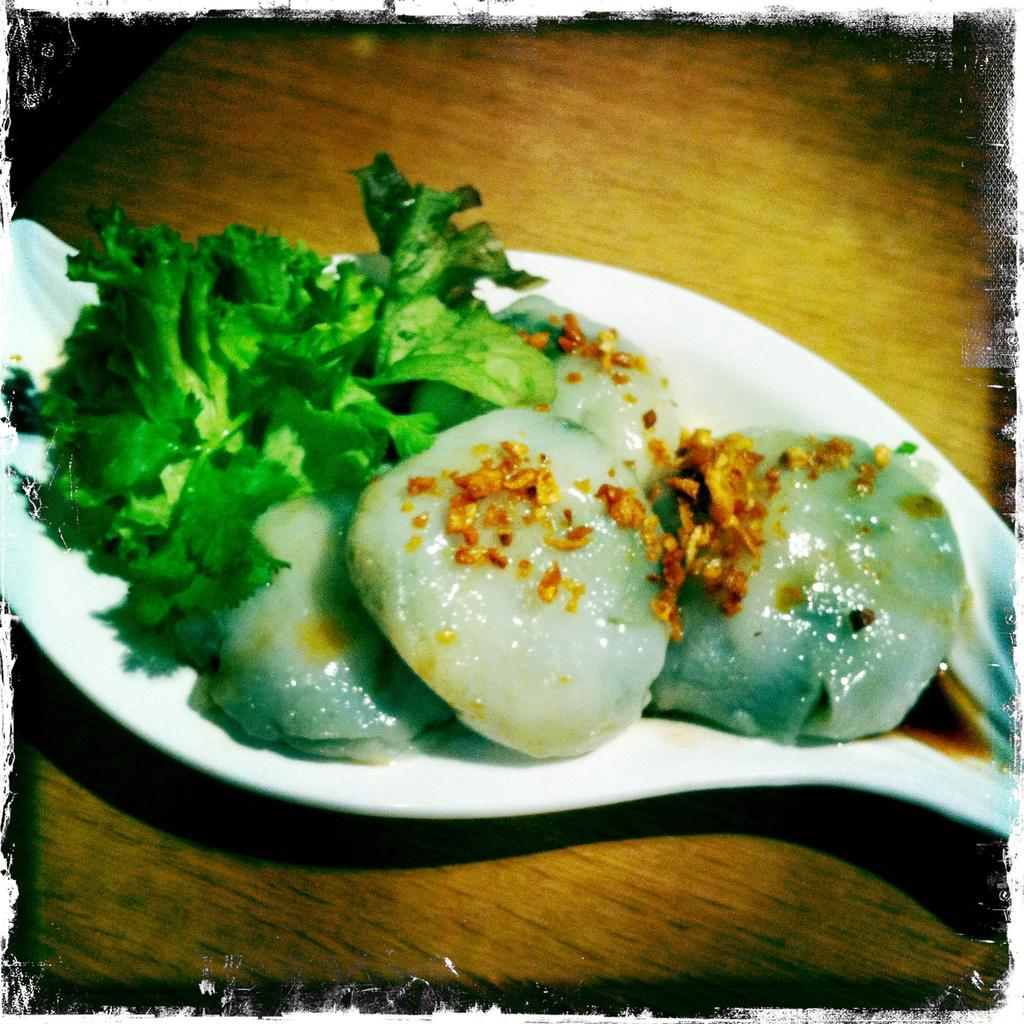What is present on the table in the image? There is a plate in the image. What color is the plate? The plate is white in color. What is on the plate? There are food items in the plate, including leafy vegetables. What is the color of the table? The plate is placed on a brown table. What type of leather is visible on the plate in the image? There is no leather present on the plate or in the image. 